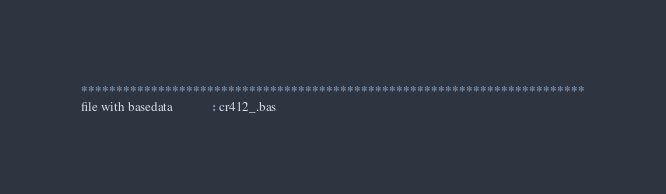Convert code to text. <code><loc_0><loc_0><loc_500><loc_500><_ObjectiveC_>************************************************************************
file with basedata            : cr412_.bas</code> 